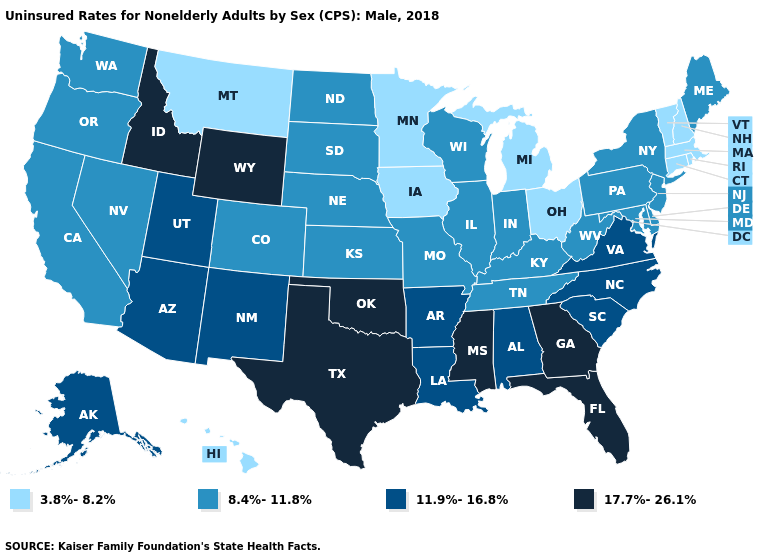What is the value of West Virginia?
Quick response, please. 8.4%-11.8%. Name the states that have a value in the range 11.9%-16.8%?
Concise answer only. Alabama, Alaska, Arizona, Arkansas, Louisiana, New Mexico, North Carolina, South Carolina, Utah, Virginia. Name the states that have a value in the range 8.4%-11.8%?
Keep it brief. California, Colorado, Delaware, Illinois, Indiana, Kansas, Kentucky, Maine, Maryland, Missouri, Nebraska, Nevada, New Jersey, New York, North Dakota, Oregon, Pennsylvania, South Dakota, Tennessee, Washington, West Virginia, Wisconsin. Name the states that have a value in the range 3.8%-8.2%?
Keep it brief. Connecticut, Hawaii, Iowa, Massachusetts, Michigan, Minnesota, Montana, New Hampshire, Ohio, Rhode Island, Vermont. Does New Hampshire have the lowest value in the USA?
Answer briefly. Yes. What is the highest value in the USA?
Write a very short answer. 17.7%-26.1%. Among the states that border Iowa , does Illinois have the lowest value?
Give a very brief answer. No. What is the value of Wisconsin?
Keep it brief. 8.4%-11.8%. What is the value of Wyoming?
Give a very brief answer. 17.7%-26.1%. What is the lowest value in the USA?
Concise answer only. 3.8%-8.2%. What is the value of Indiana?
Quick response, please. 8.4%-11.8%. What is the value of Pennsylvania?
Concise answer only. 8.4%-11.8%. Does the first symbol in the legend represent the smallest category?
Write a very short answer. Yes. Name the states that have a value in the range 8.4%-11.8%?
Give a very brief answer. California, Colorado, Delaware, Illinois, Indiana, Kansas, Kentucky, Maine, Maryland, Missouri, Nebraska, Nevada, New Jersey, New York, North Dakota, Oregon, Pennsylvania, South Dakota, Tennessee, Washington, West Virginia, Wisconsin. What is the value of Idaho?
Quick response, please. 17.7%-26.1%. 